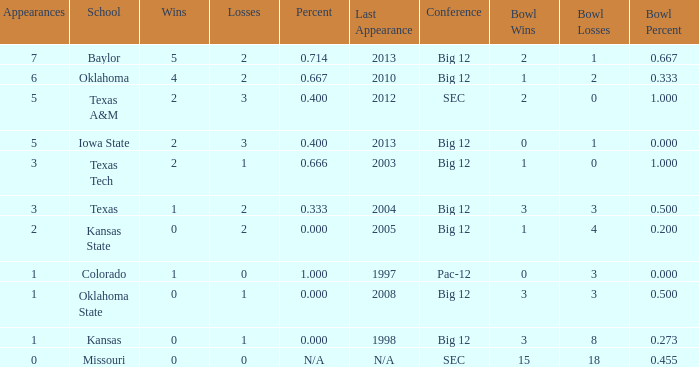What's the largest amount of wins Texas has?  1.0. 